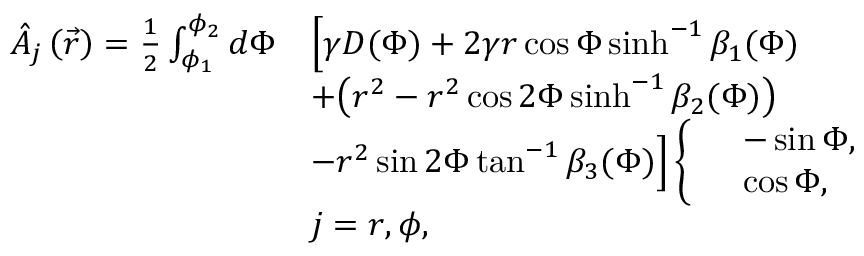Convert formula to latex. <formula><loc_0><loc_0><loc_500><loc_500>\begin{array} { r l } { \hat { A } _ { j } \left ( \vec { r } \right ) = \frac { 1 } { 2 } \int _ { \phi _ { 1 } } ^ { \phi _ { 2 } } d \Phi } & { \left [ \gamma D ( \Phi ) + 2 \gamma r \cos { \Phi } \sinh ^ { - 1 } { \beta _ { 1 } ( \Phi ) } } \\ & { + \left ( r ^ { 2 } - r ^ { 2 } \cos { 2 \Phi } \sinh ^ { - 1 } { \beta _ { 2 } ( \Phi ) } \right ) } \\ & { - r ^ { 2 } \sin { 2 \Phi } \tan ^ { - 1 } { \beta _ { 3 } ( \Phi ) } \right ] \left \{ \begin{array} { l l } & { - \sin { \Phi } , } \\ & { \cos { \Phi } , } \end{array} } \\ & { j = r , \phi , } \end{array}</formula> 